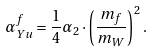<formula> <loc_0><loc_0><loc_500><loc_500>\alpha _ { Y u } ^ { f } = \frac { 1 } { 4 } \alpha _ { 2 } \cdot \left ( \frac { m _ { f } } { m _ { W } } \right ) ^ { 2 } .</formula> 